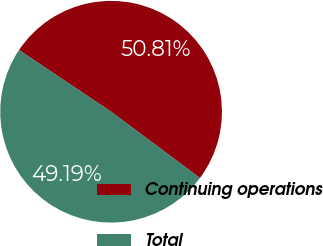Convert chart to OTSL. <chart><loc_0><loc_0><loc_500><loc_500><pie_chart><fcel>Continuing operations<fcel>Total<nl><fcel>50.81%<fcel>49.19%<nl></chart> 